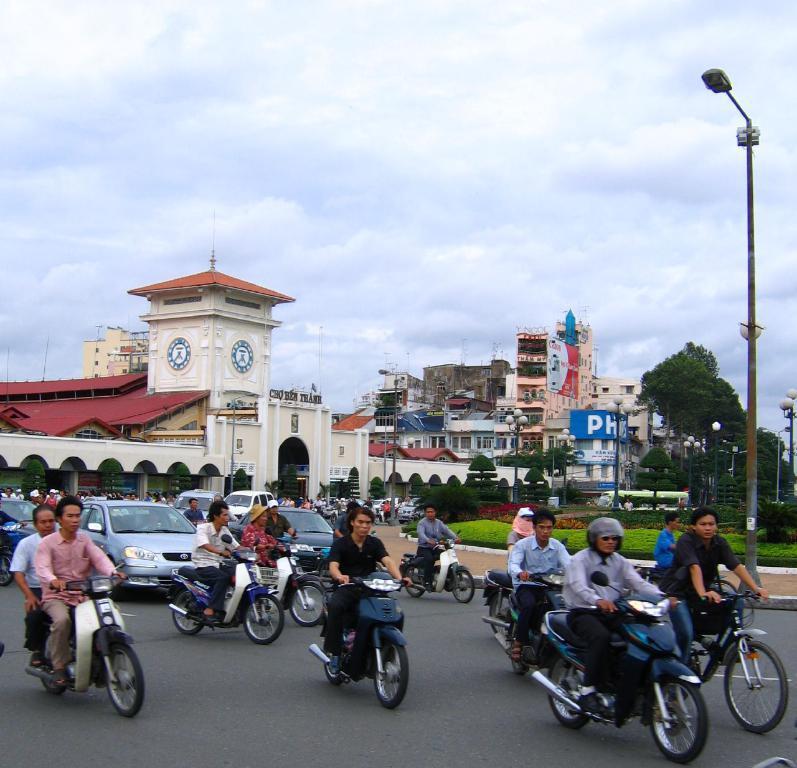Can you describe this image briefly? In the foreground of the picture there are motorbikes, people, cars, plants, street light, pavement and road. In the center of the picture there are trees, street lights and buildings. Sky is cloudy. 